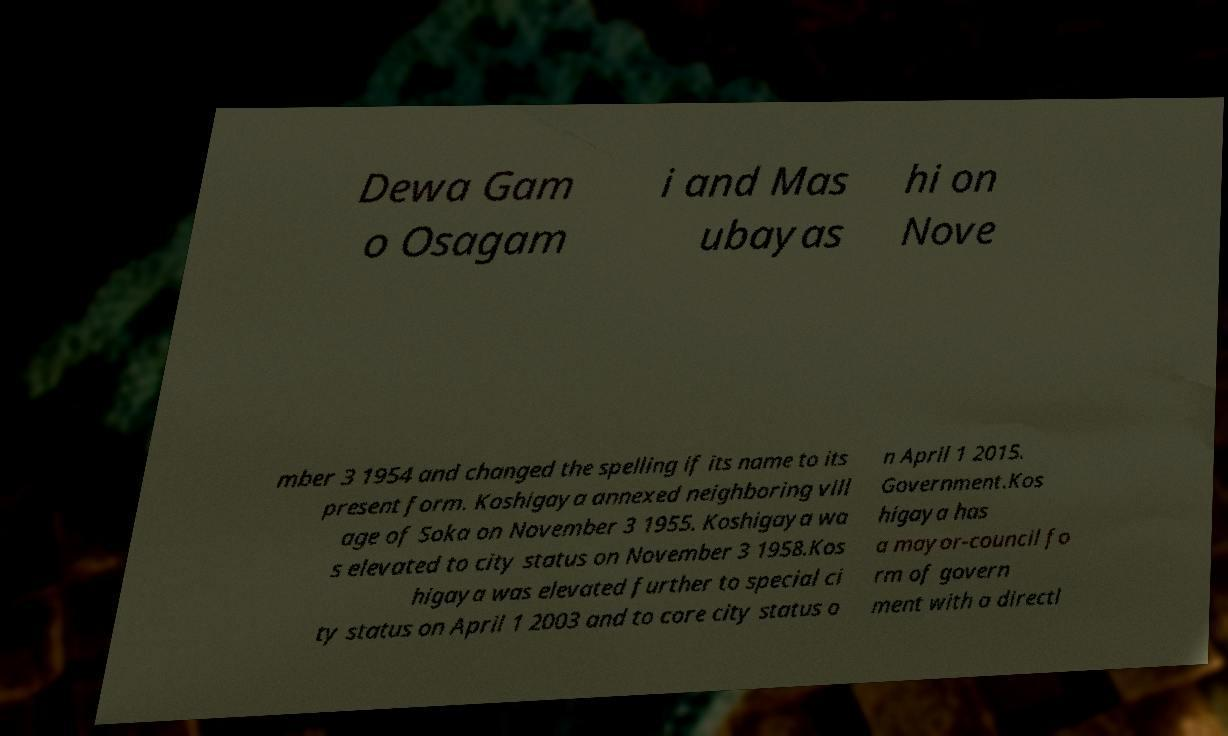Can you accurately transcribe the text from the provided image for me? Dewa Gam o Osagam i and Mas ubayas hi on Nove mber 3 1954 and changed the spelling if its name to its present form. Koshigaya annexed neighboring vill age of Soka on November 3 1955. Koshigaya wa s elevated to city status on November 3 1958.Kos higaya was elevated further to special ci ty status on April 1 2003 and to core city status o n April 1 2015. Government.Kos higaya has a mayor-council fo rm of govern ment with a directl 